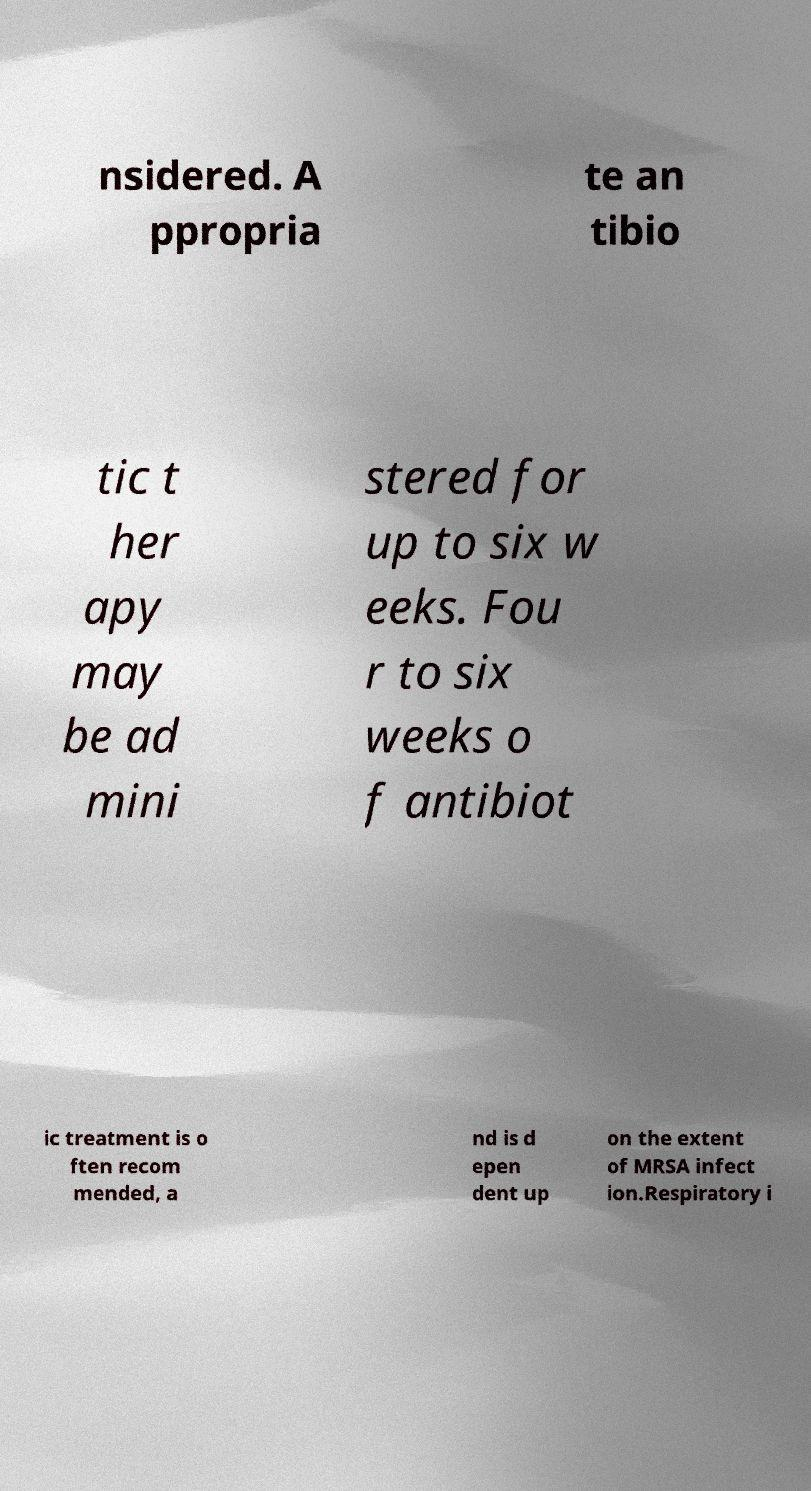Can you accurately transcribe the text from the provided image for me? nsidered. A ppropria te an tibio tic t her apy may be ad mini stered for up to six w eeks. Fou r to six weeks o f antibiot ic treatment is o ften recom mended, a nd is d epen dent up on the extent of MRSA infect ion.Respiratory i 